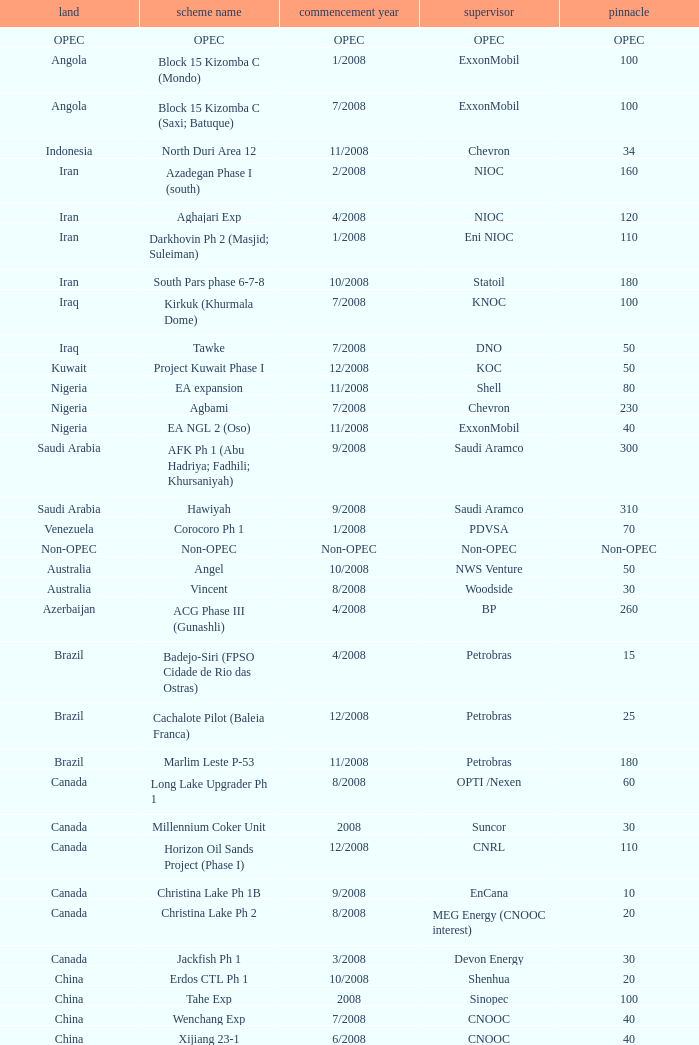What is the Operator with a Peak that is 55? PEMEX. 